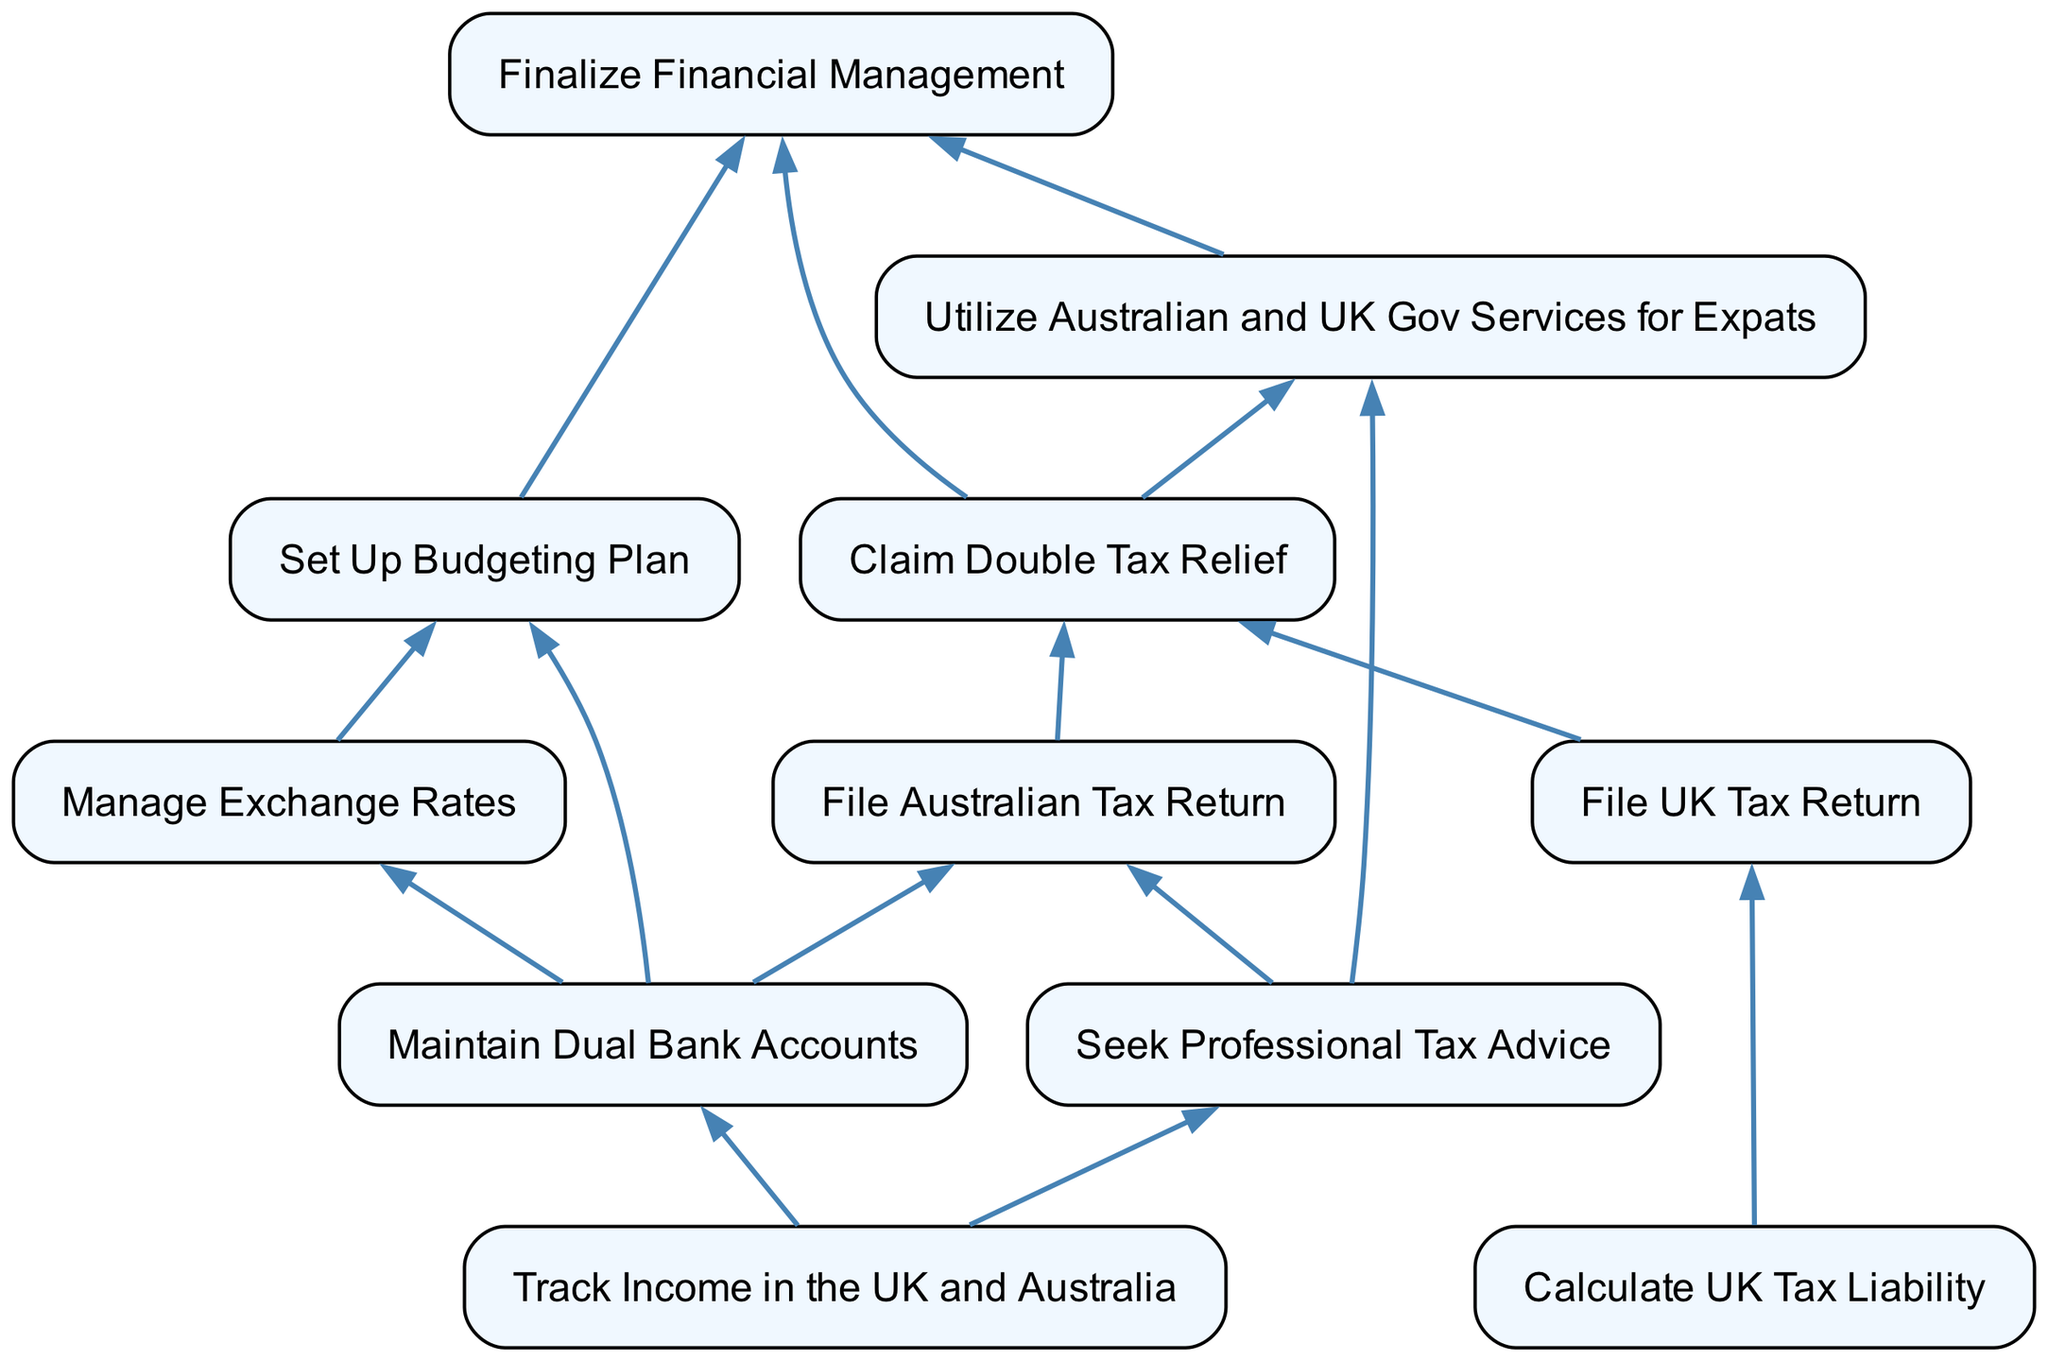What is the first step in managing finances as an Australian expatriate in the UK? The first step indicated in the diagram is "Track Income in the UK and Australia," as it is positioned at the bottom and does not depend on any prior actions.
Answer: Track Income in the UK and Australia How many nodes are there in the diagram? Counting all the unique elements listed in the diagram, there are a total of ten nodes representing various steps in managing finances and taxes as an expat.
Answer: Ten Which step requires maintaining dual bank accounts? The step "File Australian Tax Return" requires maintaining dual bank accounts as it depends on the output of "Seek Professional Tax Advice" and "Maintain Dual Bank Accounts."
Answer: Maintain Dual Bank Accounts What is the relationship between "Calculate UK Tax Liability" and "File UK Tax Return"? "File UK Tax Return" directly depends on "Calculate UK Tax Liability," which means that the calculation of tax liability must precede filing the tax return.
Answer: Depends Which two steps need to be completed before claiming double tax relief? To claim double tax relief, both "File UK Tax Return" and "File Australian Tax Return" must be completed, as indicated by the arrows directing toward "Claim Double Tax Relief."
Answer: File UK Tax Return, File Australian Tax Return What are the last three steps that need to be executed in the process? The last three steps, based on the flow of the diagram, are "Finalize Financial Management," "Utilize Australian and UK Gov Services for Expats," and "Claim Double Tax Relief," as they are positioned towards the top of the flowchart.
Answer: Finalize Financial Management, Utilize Australian and UK Gov Services for Expats, Claim Double Tax Relief What must be completed before establishing a budgeting plan? Before setting up a budgeting plan, one must complete "Maintain Dual Bank Accounts" and "Manage Exchange Rates," as both steps are prerequisites for establishing the budgeting plan according to the diagram.
Answer: Maintain Dual Bank Accounts, Manage Exchange Rates Which step involves professional assistance? The step "Seek Professional Tax Advice" explicitly mentions the need for professional assistance in managing finances and taxes as an expat.
Answer: Seek Professional Tax Advice 